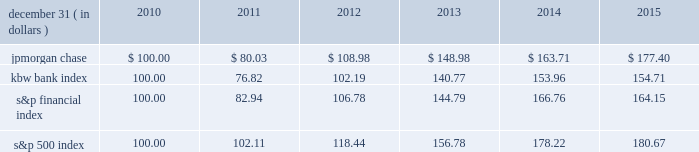Jpmorgan chase & co./2015 annual report 67 five-year stock performance the table and graph compare the five-year cumulative total return for jpmorgan chase & co .
( 201cjpmorgan chase 201d or the 201cfirm 201d ) common stock with the cumulative return of the s&p 500 index , the kbw bank index and the s&p financial index .
The s&p 500 index is a commonly referenced united states of america ( 201cu.s . 201d ) equity benchmark consisting of leading companies from different economic sectors .
The kbw bank index seeks to reflect the performance of banks and thrifts that are publicly traded in the u.s .
And is composed of 24 leading national money center and regional banks and thrifts .
The s&p financial index is an index of 87 financial companies , all of which are components of the s&p 500 .
The firm is a component of all three industry indices .
The table and graph assume simultaneous investments of $ 100 on december 31 , 2010 , in jpmorgan chase common stock and in each of the above indices .
The comparison assumes that all dividends are reinvested .
December 31 , ( in dollars ) 2010 2011 2012 2013 2014 2015 .
December 31 , ( in dollars ) .
Based on the review of the simultaneous investments in pmorgan chase common stock in various indices what was the ratio of the performance in the jpmorgan chase to kbw bank index in 2015? 
Computations: (177.40 / 154.71)
Answer: 1.14666. 